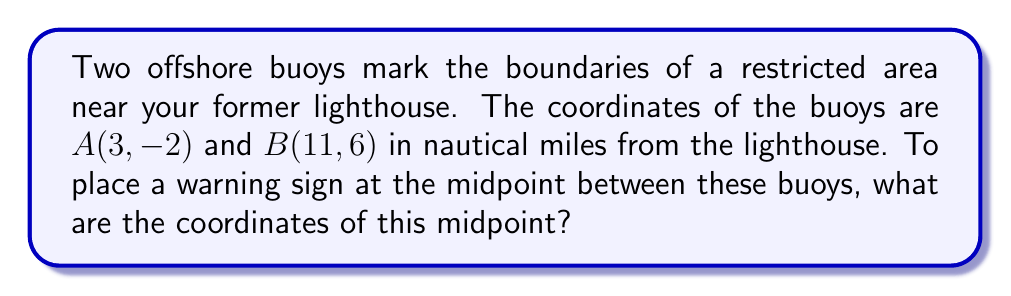What is the answer to this math problem? To find the midpoint between two points, we use the midpoint formula:

$$ \text{Midpoint} = \left(\frac{x_1 + x_2}{2}, \frac{y_1 + y_2}{2}\right) $$

Where $(x_1, y_1)$ are the coordinates of the first point and $(x_2, y_2)$ are the coordinates of the second point.

For our buoys:
$A(x_1, y_1) = (3, -2)$
$B(x_2, y_2) = (11, 6)$

Let's calculate the x-coordinate of the midpoint:
$$ x = \frac{x_1 + x_2}{2} = \frac{3 + 11}{2} = \frac{14}{2} = 7 $$

Now, let's calculate the y-coordinate of the midpoint:
$$ y = \frac{y_1 + y_2}{2} = \frac{-2 + 6}{2} = \frac{4}{2} = 2 $$

Therefore, the coordinates of the midpoint are $(7, 2)$.

[asy]
unitsize(1cm);
dot((3,-2));
dot((11,6));
dot((7,2));
label("A(3,-2)", (3,-2), SW);
label("B(11,6)", (11,6), NE);
label("Midpoint(7,2)", (7,2), SE);
draw((3,-2)--(11,6), dashed);
[/asy]
Answer: $(7, 2)$ 